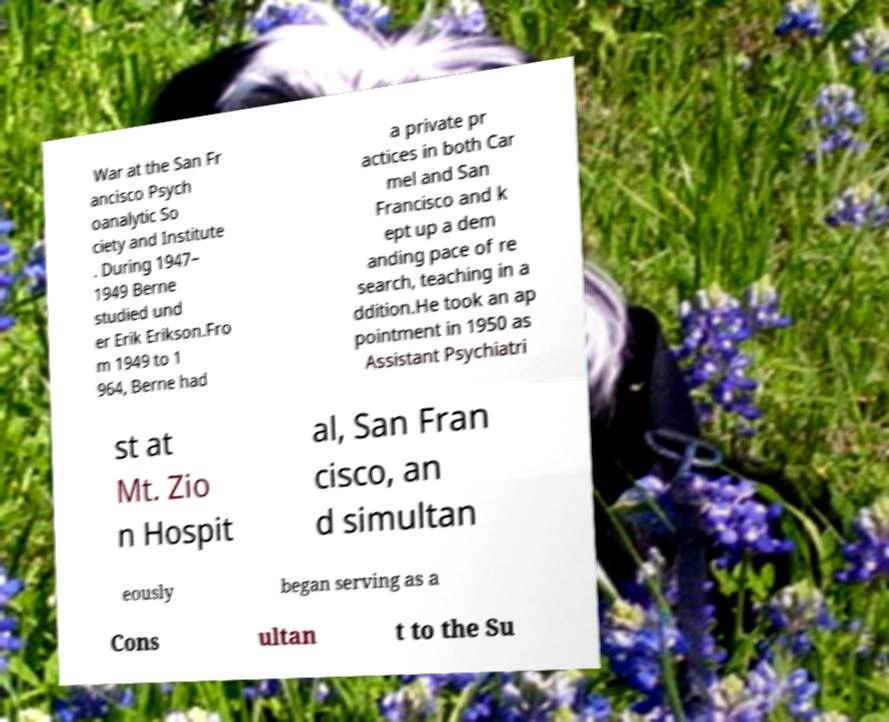Can you accurately transcribe the text from the provided image for me? War at the San Fr ancisco Psych oanalytic So ciety and Institute . During 1947– 1949 Berne studied und er Erik Erikson.Fro m 1949 to 1 964, Berne had a private pr actices in both Car mel and San Francisco and k ept up a dem anding pace of re search, teaching in a ddition.He took an ap pointment in 1950 as Assistant Psychiatri st at Mt. Zio n Hospit al, San Fran cisco, an d simultan eously began serving as a Cons ultan t to the Su 